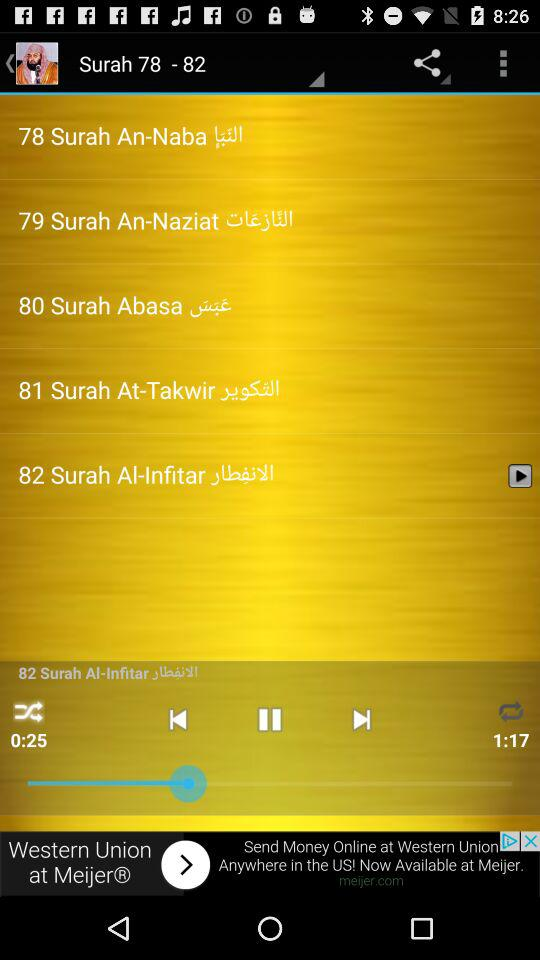How long has the song been playing? The song has been playing for 25 seconds. 